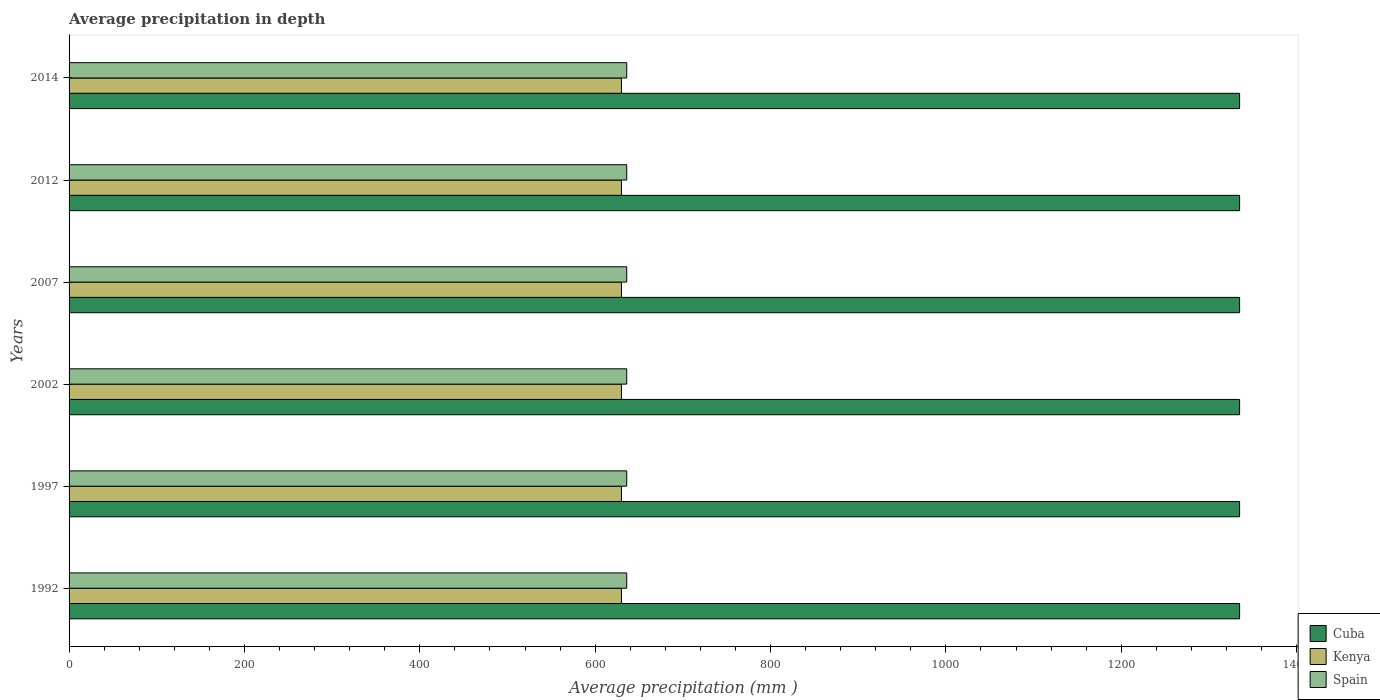How many groups of bars are there?
Give a very brief answer. 6. Are the number of bars per tick equal to the number of legend labels?
Make the answer very short. Yes. How many bars are there on the 3rd tick from the top?
Keep it short and to the point. 3. In how many cases, is the number of bars for a given year not equal to the number of legend labels?
Your answer should be very brief. 0. What is the average precipitation in Kenya in 2002?
Provide a short and direct response. 630. Across all years, what is the maximum average precipitation in Spain?
Your answer should be compact. 636. Across all years, what is the minimum average precipitation in Spain?
Ensure brevity in your answer.  636. In which year was the average precipitation in Cuba minimum?
Your answer should be compact. 1992. What is the total average precipitation in Spain in the graph?
Make the answer very short. 3816. What is the difference between the average precipitation in Spain in 1997 and the average precipitation in Cuba in 2002?
Your answer should be compact. -699. What is the average average precipitation in Kenya per year?
Provide a short and direct response. 630. In the year 1997, what is the difference between the average precipitation in Kenya and average precipitation in Spain?
Your answer should be compact. -6. What is the ratio of the average precipitation in Kenya in 1992 to that in 2002?
Offer a terse response. 1. What is the difference between the highest and the lowest average precipitation in Kenya?
Offer a very short reply. 0. In how many years, is the average precipitation in Cuba greater than the average average precipitation in Cuba taken over all years?
Provide a short and direct response. 0. What does the 2nd bar from the top in 2007 represents?
Offer a terse response. Kenya. What does the 1st bar from the bottom in 1997 represents?
Ensure brevity in your answer.  Cuba. How many bars are there?
Provide a short and direct response. 18. Are the values on the major ticks of X-axis written in scientific E-notation?
Keep it short and to the point. No. Does the graph contain grids?
Ensure brevity in your answer.  No. What is the title of the graph?
Make the answer very short. Average precipitation in depth. Does "Paraguay" appear as one of the legend labels in the graph?
Provide a short and direct response. No. What is the label or title of the X-axis?
Ensure brevity in your answer.  Average precipitation (mm ). What is the label or title of the Y-axis?
Offer a very short reply. Years. What is the Average precipitation (mm ) of Cuba in 1992?
Ensure brevity in your answer.  1335. What is the Average precipitation (mm ) of Kenya in 1992?
Make the answer very short. 630. What is the Average precipitation (mm ) of Spain in 1992?
Make the answer very short. 636. What is the Average precipitation (mm ) in Cuba in 1997?
Make the answer very short. 1335. What is the Average precipitation (mm ) of Kenya in 1997?
Provide a short and direct response. 630. What is the Average precipitation (mm ) in Spain in 1997?
Your answer should be very brief. 636. What is the Average precipitation (mm ) of Cuba in 2002?
Your response must be concise. 1335. What is the Average precipitation (mm ) of Kenya in 2002?
Provide a succinct answer. 630. What is the Average precipitation (mm ) in Spain in 2002?
Offer a terse response. 636. What is the Average precipitation (mm ) in Cuba in 2007?
Provide a short and direct response. 1335. What is the Average precipitation (mm ) in Kenya in 2007?
Offer a terse response. 630. What is the Average precipitation (mm ) in Spain in 2007?
Your answer should be very brief. 636. What is the Average precipitation (mm ) of Cuba in 2012?
Provide a short and direct response. 1335. What is the Average precipitation (mm ) of Kenya in 2012?
Make the answer very short. 630. What is the Average precipitation (mm ) in Spain in 2012?
Offer a terse response. 636. What is the Average precipitation (mm ) in Cuba in 2014?
Ensure brevity in your answer.  1335. What is the Average precipitation (mm ) of Kenya in 2014?
Your response must be concise. 630. What is the Average precipitation (mm ) in Spain in 2014?
Give a very brief answer. 636. Across all years, what is the maximum Average precipitation (mm ) of Cuba?
Offer a very short reply. 1335. Across all years, what is the maximum Average precipitation (mm ) in Kenya?
Your answer should be very brief. 630. Across all years, what is the maximum Average precipitation (mm ) of Spain?
Provide a short and direct response. 636. Across all years, what is the minimum Average precipitation (mm ) in Cuba?
Your response must be concise. 1335. Across all years, what is the minimum Average precipitation (mm ) of Kenya?
Make the answer very short. 630. Across all years, what is the minimum Average precipitation (mm ) of Spain?
Make the answer very short. 636. What is the total Average precipitation (mm ) in Cuba in the graph?
Offer a very short reply. 8010. What is the total Average precipitation (mm ) of Kenya in the graph?
Your answer should be very brief. 3780. What is the total Average precipitation (mm ) of Spain in the graph?
Your answer should be compact. 3816. What is the difference between the Average precipitation (mm ) in Spain in 1992 and that in 1997?
Give a very brief answer. 0. What is the difference between the Average precipitation (mm ) of Kenya in 1992 and that in 2002?
Offer a terse response. 0. What is the difference between the Average precipitation (mm ) of Cuba in 1992 and that in 2007?
Provide a short and direct response. 0. What is the difference between the Average precipitation (mm ) of Spain in 1992 and that in 2007?
Make the answer very short. 0. What is the difference between the Average precipitation (mm ) of Kenya in 1992 and that in 2012?
Offer a very short reply. 0. What is the difference between the Average precipitation (mm ) in Spain in 1992 and that in 2012?
Give a very brief answer. 0. What is the difference between the Average precipitation (mm ) in Kenya in 1992 and that in 2014?
Offer a terse response. 0. What is the difference between the Average precipitation (mm ) in Spain in 1992 and that in 2014?
Give a very brief answer. 0. What is the difference between the Average precipitation (mm ) of Cuba in 1997 and that in 2002?
Your response must be concise. 0. What is the difference between the Average precipitation (mm ) in Spain in 1997 and that in 2002?
Make the answer very short. 0. What is the difference between the Average precipitation (mm ) in Cuba in 1997 and that in 2007?
Your answer should be compact. 0. What is the difference between the Average precipitation (mm ) in Kenya in 1997 and that in 2007?
Provide a succinct answer. 0. What is the difference between the Average precipitation (mm ) of Spain in 1997 and that in 2007?
Your answer should be very brief. 0. What is the difference between the Average precipitation (mm ) of Cuba in 1997 and that in 2012?
Your answer should be compact. 0. What is the difference between the Average precipitation (mm ) in Kenya in 1997 and that in 2012?
Offer a very short reply. 0. What is the difference between the Average precipitation (mm ) in Cuba in 1997 and that in 2014?
Your answer should be very brief. 0. What is the difference between the Average precipitation (mm ) of Kenya in 1997 and that in 2014?
Make the answer very short. 0. What is the difference between the Average precipitation (mm ) of Spain in 1997 and that in 2014?
Your response must be concise. 0. What is the difference between the Average precipitation (mm ) of Cuba in 2002 and that in 2007?
Your answer should be very brief. 0. What is the difference between the Average precipitation (mm ) of Cuba in 2002 and that in 2012?
Offer a terse response. 0. What is the difference between the Average precipitation (mm ) of Cuba in 2002 and that in 2014?
Provide a short and direct response. 0. What is the difference between the Average precipitation (mm ) of Spain in 2002 and that in 2014?
Make the answer very short. 0. What is the difference between the Average precipitation (mm ) in Kenya in 2007 and that in 2012?
Your answer should be very brief. 0. What is the difference between the Average precipitation (mm ) in Spain in 2007 and that in 2014?
Your answer should be very brief. 0. What is the difference between the Average precipitation (mm ) of Cuba in 2012 and that in 2014?
Keep it short and to the point. 0. What is the difference between the Average precipitation (mm ) in Cuba in 1992 and the Average precipitation (mm ) in Kenya in 1997?
Provide a short and direct response. 705. What is the difference between the Average precipitation (mm ) in Cuba in 1992 and the Average precipitation (mm ) in Spain in 1997?
Ensure brevity in your answer.  699. What is the difference between the Average precipitation (mm ) in Cuba in 1992 and the Average precipitation (mm ) in Kenya in 2002?
Offer a very short reply. 705. What is the difference between the Average precipitation (mm ) in Cuba in 1992 and the Average precipitation (mm ) in Spain in 2002?
Your response must be concise. 699. What is the difference between the Average precipitation (mm ) of Cuba in 1992 and the Average precipitation (mm ) of Kenya in 2007?
Offer a terse response. 705. What is the difference between the Average precipitation (mm ) of Cuba in 1992 and the Average precipitation (mm ) of Spain in 2007?
Keep it short and to the point. 699. What is the difference between the Average precipitation (mm ) of Cuba in 1992 and the Average precipitation (mm ) of Kenya in 2012?
Offer a terse response. 705. What is the difference between the Average precipitation (mm ) of Cuba in 1992 and the Average precipitation (mm ) of Spain in 2012?
Give a very brief answer. 699. What is the difference between the Average precipitation (mm ) of Kenya in 1992 and the Average precipitation (mm ) of Spain in 2012?
Give a very brief answer. -6. What is the difference between the Average precipitation (mm ) in Cuba in 1992 and the Average precipitation (mm ) in Kenya in 2014?
Keep it short and to the point. 705. What is the difference between the Average precipitation (mm ) of Cuba in 1992 and the Average precipitation (mm ) of Spain in 2014?
Keep it short and to the point. 699. What is the difference between the Average precipitation (mm ) of Cuba in 1997 and the Average precipitation (mm ) of Kenya in 2002?
Offer a very short reply. 705. What is the difference between the Average precipitation (mm ) of Cuba in 1997 and the Average precipitation (mm ) of Spain in 2002?
Give a very brief answer. 699. What is the difference between the Average precipitation (mm ) of Cuba in 1997 and the Average precipitation (mm ) of Kenya in 2007?
Provide a short and direct response. 705. What is the difference between the Average precipitation (mm ) in Cuba in 1997 and the Average precipitation (mm ) in Spain in 2007?
Your response must be concise. 699. What is the difference between the Average precipitation (mm ) in Kenya in 1997 and the Average precipitation (mm ) in Spain in 2007?
Your answer should be very brief. -6. What is the difference between the Average precipitation (mm ) of Cuba in 1997 and the Average precipitation (mm ) of Kenya in 2012?
Ensure brevity in your answer.  705. What is the difference between the Average precipitation (mm ) of Cuba in 1997 and the Average precipitation (mm ) of Spain in 2012?
Provide a succinct answer. 699. What is the difference between the Average precipitation (mm ) of Cuba in 1997 and the Average precipitation (mm ) of Kenya in 2014?
Your answer should be very brief. 705. What is the difference between the Average precipitation (mm ) in Cuba in 1997 and the Average precipitation (mm ) in Spain in 2014?
Offer a very short reply. 699. What is the difference between the Average precipitation (mm ) in Cuba in 2002 and the Average precipitation (mm ) in Kenya in 2007?
Offer a very short reply. 705. What is the difference between the Average precipitation (mm ) of Cuba in 2002 and the Average precipitation (mm ) of Spain in 2007?
Offer a terse response. 699. What is the difference between the Average precipitation (mm ) of Kenya in 2002 and the Average precipitation (mm ) of Spain in 2007?
Offer a terse response. -6. What is the difference between the Average precipitation (mm ) in Cuba in 2002 and the Average precipitation (mm ) in Kenya in 2012?
Make the answer very short. 705. What is the difference between the Average precipitation (mm ) in Cuba in 2002 and the Average precipitation (mm ) in Spain in 2012?
Offer a very short reply. 699. What is the difference between the Average precipitation (mm ) in Kenya in 2002 and the Average precipitation (mm ) in Spain in 2012?
Make the answer very short. -6. What is the difference between the Average precipitation (mm ) in Cuba in 2002 and the Average precipitation (mm ) in Kenya in 2014?
Your answer should be very brief. 705. What is the difference between the Average precipitation (mm ) of Cuba in 2002 and the Average precipitation (mm ) of Spain in 2014?
Provide a succinct answer. 699. What is the difference between the Average precipitation (mm ) in Kenya in 2002 and the Average precipitation (mm ) in Spain in 2014?
Your answer should be compact. -6. What is the difference between the Average precipitation (mm ) of Cuba in 2007 and the Average precipitation (mm ) of Kenya in 2012?
Your response must be concise. 705. What is the difference between the Average precipitation (mm ) in Cuba in 2007 and the Average precipitation (mm ) in Spain in 2012?
Offer a very short reply. 699. What is the difference between the Average precipitation (mm ) in Cuba in 2007 and the Average precipitation (mm ) in Kenya in 2014?
Provide a succinct answer. 705. What is the difference between the Average precipitation (mm ) of Cuba in 2007 and the Average precipitation (mm ) of Spain in 2014?
Your answer should be very brief. 699. What is the difference between the Average precipitation (mm ) of Kenya in 2007 and the Average precipitation (mm ) of Spain in 2014?
Offer a very short reply. -6. What is the difference between the Average precipitation (mm ) in Cuba in 2012 and the Average precipitation (mm ) in Kenya in 2014?
Offer a terse response. 705. What is the difference between the Average precipitation (mm ) in Cuba in 2012 and the Average precipitation (mm ) in Spain in 2014?
Offer a terse response. 699. What is the difference between the Average precipitation (mm ) in Kenya in 2012 and the Average precipitation (mm ) in Spain in 2014?
Provide a succinct answer. -6. What is the average Average precipitation (mm ) in Cuba per year?
Keep it short and to the point. 1335. What is the average Average precipitation (mm ) of Kenya per year?
Provide a short and direct response. 630. What is the average Average precipitation (mm ) of Spain per year?
Give a very brief answer. 636. In the year 1992, what is the difference between the Average precipitation (mm ) in Cuba and Average precipitation (mm ) in Kenya?
Your response must be concise. 705. In the year 1992, what is the difference between the Average precipitation (mm ) of Cuba and Average precipitation (mm ) of Spain?
Provide a short and direct response. 699. In the year 1992, what is the difference between the Average precipitation (mm ) in Kenya and Average precipitation (mm ) in Spain?
Provide a short and direct response. -6. In the year 1997, what is the difference between the Average precipitation (mm ) of Cuba and Average precipitation (mm ) of Kenya?
Provide a succinct answer. 705. In the year 1997, what is the difference between the Average precipitation (mm ) of Cuba and Average precipitation (mm ) of Spain?
Provide a short and direct response. 699. In the year 1997, what is the difference between the Average precipitation (mm ) in Kenya and Average precipitation (mm ) in Spain?
Make the answer very short. -6. In the year 2002, what is the difference between the Average precipitation (mm ) of Cuba and Average precipitation (mm ) of Kenya?
Your response must be concise. 705. In the year 2002, what is the difference between the Average precipitation (mm ) in Cuba and Average precipitation (mm ) in Spain?
Make the answer very short. 699. In the year 2007, what is the difference between the Average precipitation (mm ) of Cuba and Average precipitation (mm ) of Kenya?
Your answer should be compact. 705. In the year 2007, what is the difference between the Average precipitation (mm ) of Cuba and Average precipitation (mm ) of Spain?
Offer a terse response. 699. In the year 2007, what is the difference between the Average precipitation (mm ) of Kenya and Average precipitation (mm ) of Spain?
Give a very brief answer. -6. In the year 2012, what is the difference between the Average precipitation (mm ) in Cuba and Average precipitation (mm ) in Kenya?
Provide a succinct answer. 705. In the year 2012, what is the difference between the Average precipitation (mm ) in Cuba and Average precipitation (mm ) in Spain?
Provide a succinct answer. 699. In the year 2014, what is the difference between the Average precipitation (mm ) of Cuba and Average precipitation (mm ) of Kenya?
Keep it short and to the point. 705. In the year 2014, what is the difference between the Average precipitation (mm ) in Cuba and Average precipitation (mm ) in Spain?
Your answer should be compact. 699. What is the ratio of the Average precipitation (mm ) in Cuba in 1992 to that in 1997?
Give a very brief answer. 1. What is the ratio of the Average precipitation (mm ) of Cuba in 1992 to that in 2002?
Your answer should be compact. 1. What is the ratio of the Average precipitation (mm ) of Spain in 1992 to that in 2002?
Provide a short and direct response. 1. What is the ratio of the Average precipitation (mm ) of Cuba in 1992 to that in 2007?
Give a very brief answer. 1. What is the ratio of the Average precipitation (mm ) of Kenya in 1992 to that in 2007?
Offer a very short reply. 1. What is the ratio of the Average precipitation (mm ) in Cuba in 1992 to that in 2012?
Provide a succinct answer. 1. What is the ratio of the Average precipitation (mm ) in Kenya in 1992 to that in 2012?
Provide a succinct answer. 1. What is the ratio of the Average precipitation (mm ) of Spain in 1992 to that in 2012?
Offer a terse response. 1. What is the ratio of the Average precipitation (mm ) in Cuba in 1992 to that in 2014?
Your answer should be very brief. 1. What is the ratio of the Average precipitation (mm ) in Kenya in 1997 to that in 2007?
Provide a succinct answer. 1. What is the ratio of the Average precipitation (mm ) of Cuba in 1997 to that in 2012?
Offer a terse response. 1. What is the ratio of the Average precipitation (mm ) in Kenya in 1997 to that in 2012?
Your answer should be compact. 1. What is the ratio of the Average precipitation (mm ) in Kenya in 1997 to that in 2014?
Offer a terse response. 1. What is the ratio of the Average precipitation (mm ) of Spain in 1997 to that in 2014?
Your response must be concise. 1. What is the ratio of the Average precipitation (mm ) in Cuba in 2002 to that in 2007?
Ensure brevity in your answer.  1. What is the ratio of the Average precipitation (mm ) in Kenya in 2002 to that in 2007?
Provide a succinct answer. 1. What is the ratio of the Average precipitation (mm ) in Cuba in 2002 to that in 2012?
Make the answer very short. 1. What is the ratio of the Average precipitation (mm ) in Spain in 2002 to that in 2012?
Provide a short and direct response. 1. What is the ratio of the Average precipitation (mm ) in Kenya in 2002 to that in 2014?
Give a very brief answer. 1. What is the ratio of the Average precipitation (mm ) of Cuba in 2007 to that in 2012?
Keep it short and to the point. 1. What is the ratio of the Average precipitation (mm ) of Spain in 2007 to that in 2012?
Provide a short and direct response. 1. What is the ratio of the Average precipitation (mm ) in Kenya in 2007 to that in 2014?
Provide a short and direct response. 1. What is the ratio of the Average precipitation (mm ) of Cuba in 2012 to that in 2014?
Keep it short and to the point. 1. What is the difference between the highest and the second highest Average precipitation (mm ) of Spain?
Give a very brief answer. 0. 